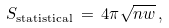Convert formula to latex. <formula><loc_0><loc_0><loc_500><loc_500>S _ { \text {statistical} } \, = \, 4 \pi \sqrt { n w } \, ,</formula> 